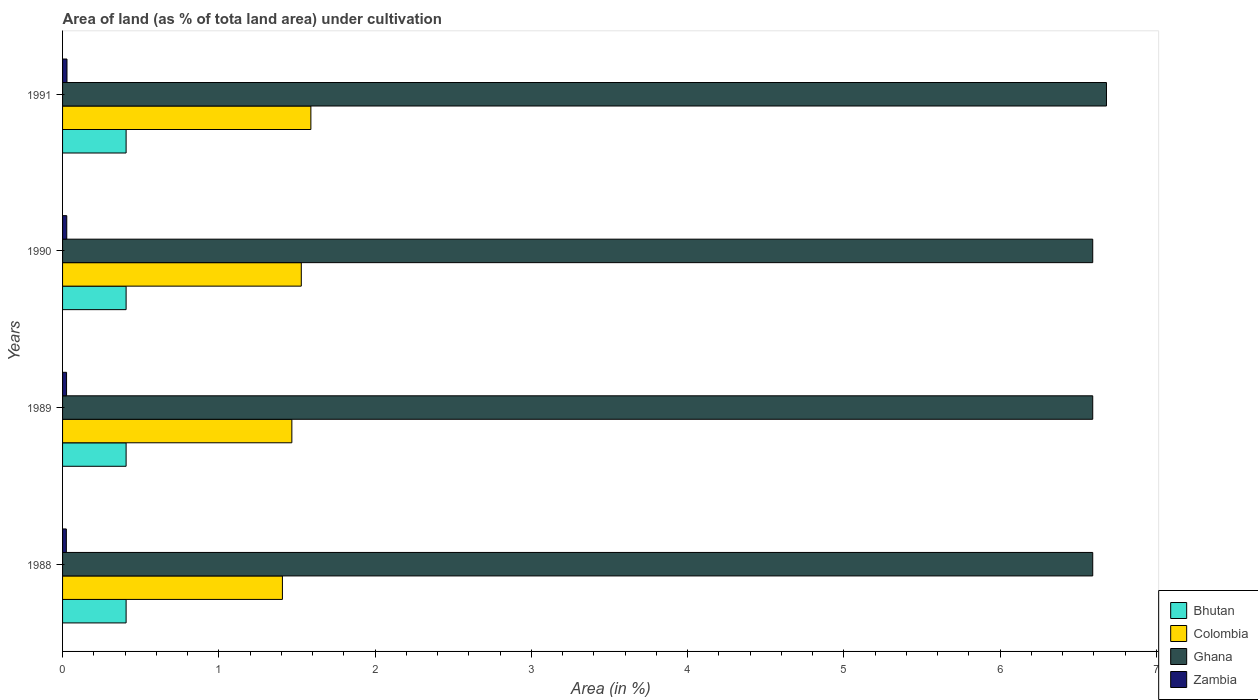How many groups of bars are there?
Your answer should be very brief. 4. How many bars are there on the 2nd tick from the top?
Your answer should be compact. 4. How many bars are there on the 2nd tick from the bottom?
Offer a terse response. 4. What is the label of the 4th group of bars from the top?
Keep it short and to the point. 1988. What is the percentage of land under cultivation in Colombia in 1990?
Your response must be concise. 1.53. Across all years, what is the maximum percentage of land under cultivation in Zambia?
Provide a succinct answer. 0.03. Across all years, what is the minimum percentage of land under cultivation in Zambia?
Make the answer very short. 0.02. In which year was the percentage of land under cultivation in Bhutan minimum?
Ensure brevity in your answer.  1988. What is the total percentage of land under cultivation in Ghana in the graph?
Offer a very short reply. 26.46. What is the difference between the percentage of land under cultivation in Colombia in 1988 and that in 1991?
Your response must be concise. -0.18. What is the difference between the percentage of land under cultivation in Zambia in 1990 and the percentage of land under cultivation in Bhutan in 1989?
Your answer should be compact. -0.38. What is the average percentage of land under cultivation in Bhutan per year?
Provide a succinct answer. 0.41. In the year 1990, what is the difference between the percentage of land under cultivation in Ghana and percentage of land under cultivation in Bhutan?
Provide a short and direct response. 6.19. In how many years, is the percentage of land under cultivation in Zambia greater than 4 %?
Your answer should be very brief. 0. What is the difference between the highest and the second highest percentage of land under cultivation in Bhutan?
Your response must be concise. 0. What is the difference between the highest and the lowest percentage of land under cultivation in Colombia?
Your response must be concise. 0.18. What does the 4th bar from the top in 1988 represents?
Provide a short and direct response. Bhutan. What does the 3rd bar from the bottom in 1989 represents?
Your answer should be very brief. Ghana. How many bars are there?
Your response must be concise. 16. Are all the bars in the graph horizontal?
Your answer should be compact. Yes. How many years are there in the graph?
Ensure brevity in your answer.  4. What is the difference between two consecutive major ticks on the X-axis?
Your answer should be very brief. 1. Does the graph contain any zero values?
Your answer should be compact. No. How many legend labels are there?
Your response must be concise. 4. How are the legend labels stacked?
Offer a terse response. Vertical. What is the title of the graph?
Your answer should be very brief. Area of land (as % of tota land area) under cultivation. What is the label or title of the X-axis?
Offer a terse response. Area (in %). What is the label or title of the Y-axis?
Your answer should be very brief. Years. What is the Area (in %) of Bhutan in 1988?
Keep it short and to the point. 0.41. What is the Area (in %) in Colombia in 1988?
Offer a very short reply. 1.41. What is the Area (in %) of Ghana in 1988?
Provide a succinct answer. 6.59. What is the Area (in %) of Zambia in 1988?
Ensure brevity in your answer.  0.02. What is the Area (in %) in Bhutan in 1989?
Offer a terse response. 0.41. What is the Area (in %) in Colombia in 1989?
Give a very brief answer. 1.47. What is the Area (in %) in Ghana in 1989?
Offer a very short reply. 6.59. What is the Area (in %) in Zambia in 1989?
Ensure brevity in your answer.  0.03. What is the Area (in %) in Bhutan in 1990?
Your response must be concise. 0.41. What is the Area (in %) of Colombia in 1990?
Your response must be concise. 1.53. What is the Area (in %) of Ghana in 1990?
Make the answer very short. 6.59. What is the Area (in %) in Zambia in 1990?
Offer a terse response. 0.03. What is the Area (in %) of Bhutan in 1991?
Provide a succinct answer. 0.41. What is the Area (in %) in Colombia in 1991?
Your answer should be compact. 1.59. What is the Area (in %) of Ghana in 1991?
Provide a succinct answer. 6.68. What is the Area (in %) in Zambia in 1991?
Ensure brevity in your answer.  0.03. Across all years, what is the maximum Area (in %) in Bhutan?
Give a very brief answer. 0.41. Across all years, what is the maximum Area (in %) in Colombia?
Give a very brief answer. 1.59. Across all years, what is the maximum Area (in %) of Ghana?
Your answer should be compact. 6.68. Across all years, what is the maximum Area (in %) of Zambia?
Offer a terse response. 0.03. Across all years, what is the minimum Area (in %) in Bhutan?
Ensure brevity in your answer.  0.41. Across all years, what is the minimum Area (in %) in Colombia?
Your answer should be compact. 1.41. Across all years, what is the minimum Area (in %) of Ghana?
Your answer should be compact. 6.59. Across all years, what is the minimum Area (in %) of Zambia?
Make the answer very short. 0.02. What is the total Area (in %) in Bhutan in the graph?
Offer a terse response. 1.63. What is the total Area (in %) in Colombia in the graph?
Your response must be concise. 5.99. What is the total Area (in %) of Ghana in the graph?
Give a very brief answer. 26.46. What is the total Area (in %) in Zambia in the graph?
Your answer should be very brief. 0.1. What is the difference between the Area (in %) of Colombia in 1988 and that in 1989?
Your response must be concise. -0.06. What is the difference between the Area (in %) in Zambia in 1988 and that in 1989?
Provide a succinct answer. -0. What is the difference between the Area (in %) of Bhutan in 1988 and that in 1990?
Offer a very short reply. 0. What is the difference between the Area (in %) in Colombia in 1988 and that in 1990?
Offer a very short reply. -0.12. What is the difference between the Area (in %) of Zambia in 1988 and that in 1990?
Your response must be concise. -0. What is the difference between the Area (in %) in Colombia in 1988 and that in 1991?
Offer a terse response. -0.18. What is the difference between the Area (in %) of Ghana in 1988 and that in 1991?
Provide a succinct answer. -0.09. What is the difference between the Area (in %) of Zambia in 1988 and that in 1991?
Your answer should be compact. -0. What is the difference between the Area (in %) of Bhutan in 1989 and that in 1990?
Provide a short and direct response. 0. What is the difference between the Area (in %) in Colombia in 1989 and that in 1990?
Provide a short and direct response. -0.06. What is the difference between the Area (in %) in Zambia in 1989 and that in 1990?
Offer a very short reply. -0. What is the difference between the Area (in %) in Colombia in 1989 and that in 1991?
Offer a very short reply. -0.12. What is the difference between the Area (in %) in Ghana in 1989 and that in 1991?
Give a very brief answer. -0.09. What is the difference between the Area (in %) in Zambia in 1989 and that in 1991?
Make the answer very short. -0. What is the difference between the Area (in %) in Bhutan in 1990 and that in 1991?
Keep it short and to the point. 0. What is the difference between the Area (in %) in Colombia in 1990 and that in 1991?
Make the answer very short. -0.06. What is the difference between the Area (in %) in Ghana in 1990 and that in 1991?
Provide a succinct answer. -0.09. What is the difference between the Area (in %) in Zambia in 1990 and that in 1991?
Make the answer very short. -0. What is the difference between the Area (in %) of Bhutan in 1988 and the Area (in %) of Colombia in 1989?
Your response must be concise. -1.06. What is the difference between the Area (in %) in Bhutan in 1988 and the Area (in %) in Ghana in 1989?
Your response must be concise. -6.19. What is the difference between the Area (in %) in Bhutan in 1988 and the Area (in %) in Zambia in 1989?
Keep it short and to the point. 0.38. What is the difference between the Area (in %) of Colombia in 1988 and the Area (in %) of Ghana in 1989?
Ensure brevity in your answer.  -5.19. What is the difference between the Area (in %) in Colombia in 1988 and the Area (in %) in Zambia in 1989?
Give a very brief answer. 1.38. What is the difference between the Area (in %) in Ghana in 1988 and the Area (in %) in Zambia in 1989?
Give a very brief answer. 6.57. What is the difference between the Area (in %) of Bhutan in 1988 and the Area (in %) of Colombia in 1990?
Make the answer very short. -1.12. What is the difference between the Area (in %) in Bhutan in 1988 and the Area (in %) in Ghana in 1990?
Offer a terse response. -6.19. What is the difference between the Area (in %) in Bhutan in 1988 and the Area (in %) in Zambia in 1990?
Keep it short and to the point. 0.38. What is the difference between the Area (in %) of Colombia in 1988 and the Area (in %) of Ghana in 1990?
Provide a succinct answer. -5.19. What is the difference between the Area (in %) of Colombia in 1988 and the Area (in %) of Zambia in 1990?
Offer a very short reply. 1.38. What is the difference between the Area (in %) of Ghana in 1988 and the Area (in %) of Zambia in 1990?
Make the answer very short. 6.57. What is the difference between the Area (in %) in Bhutan in 1988 and the Area (in %) in Colombia in 1991?
Give a very brief answer. -1.18. What is the difference between the Area (in %) of Bhutan in 1988 and the Area (in %) of Ghana in 1991?
Your response must be concise. -6.27. What is the difference between the Area (in %) of Bhutan in 1988 and the Area (in %) of Zambia in 1991?
Provide a short and direct response. 0.38. What is the difference between the Area (in %) in Colombia in 1988 and the Area (in %) in Ghana in 1991?
Provide a succinct answer. -5.27. What is the difference between the Area (in %) in Colombia in 1988 and the Area (in %) in Zambia in 1991?
Provide a succinct answer. 1.38. What is the difference between the Area (in %) of Ghana in 1988 and the Area (in %) of Zambia in 1991?
Ensure brevity in your answer.  6.56. What is the difference between the Area (in %) of Bhutan in 1989 and the Area (in %) of Colombia in 1990?
Your answer should be compact. -1.12. What is the difference between the Area (in %) of Bhutan in 1989 and the Area (in %) of Ghana in 1990?
Give a very brief answer. -6.19. What is the difference between the Area (in %) of Bhutan in 1989 and the Area (in %) of Zambia in 1990?
Your answer should be very brief. 0.38. What is the difference between the Area (in %) of Colombia in 1989 and the Area (in %) of Ghana in 1990?
Make the answer very short. -5.12. What is the difference between the Area (in %) of Colombia in 1989 and the Area (in %) of Zambia in 1990?
Keep it short and to the point. 1.44. What is the difference between the Area (in %) in Ghana in 1989 and the Area (in %) in Zambia in 1990?
Give a very brief answer. 6.57. What is the difference between the Area (in %) of Bhutan in 1989 and the Area (in %) of Colombia in 1991?
Your answer should be very brief. -1.18. What is the difference between the Area (in %) of Bhutan in 1989 and the Area (in %) of Ghana in 1991?
Make the answer very short. -6.27. What is the difference between the Area (in %) of Bhutan in 1989 and the Area (in %) of Zambia in 1991?
Give a very brief answer. 0.38. What is the difference between the Area (in %) in Colombia in 1989 and the Area (in %) in Ghana in 1991?
Offer a very short reply. -5.21. What is the difference between the Area (in %) of Colombia in 1989 and the Area (in %) of Zambia in 1991?
Keep it short and to the point. 1.44. What is the difference between the Area (in %) in Ghana in 1989 and the Area (in %) in Zambia in 1991?
Keep it short and to the point. 6.56. What is the difference between the Area (in %) of Bhutan in 1990 and the Area (in %) of Colombia in 1991?
Give a very brief answer. -1.18. What is the difference between the Area (in %) in Bhutan in 1990 and the Area (in %) in Ghana in 1991?
Provide a short and direct response. -6.27. What is the difference between the Area (in %) in Bhutan in 1990 and the Area (in %) in Zambia in 1991?
Give a very brief answer. 0.38. What is the difference between the Area (in %) in Colombia in 1990 and the Area (in %) in Ghana in 1991?
Offer a terse response. -5.15. What is the difference between the Area (in %) of Colombia in 1990 and the Area (in %) of Zambia in 1991?
Offer a very short reply. 1.5. What is the difference between the Area (in %) in Ghana in 1990 and the Area (in %) in Zambia in 1991?
Offer a terse response. 6.56. What is the average Area (in %) of Bhutan per year?
Ensure brevity in your answer.  0.41. What is the average Area (in %) of Colombia per year?
Your answer should be compact. 1.5. What is the average Area (in %) of Ghana per year?
Make the answer very short. 6.61. What is the average Area (in %) of Zambia per year?
Offer a very short reply. 0.03. In the year 1988, what is the difference between the Area (in %) of Bhutan and Area (in %) of Colombia?
Offer a terse response. -1. In the year 1988, what is the difference between the Area (in %) of Bhutan and Area (in %) of Ghana?
Offer a terse response. -6.19. In the year 1988, what is the difference between the Area (in %) in Bhutan and Area (in %) in Zambia?
Give a very brief answer. 0.38. In the year 1988, what is the difference between the Area (in %) in Colombia and Area (in %) in Ghana?
Keep it short and to the point. -5.19. In the year 1988, what is the difference between the Area (in %) of Colombia and Area (in %) of Zambia?
Ensure brevity in your answer.  1.38. In the year 1988, what is the difference between the Area (in %) of Ghana and Area (in %) of Zambia?
Offer a terse response. 6.57. In the year 1989, what is the difference between the Area (in %) in Bhutan and Area (in %) in Colombia?
Your answer should be very brief. -1.06. In the year 1989, what is the difference between the Area (in %) of Bhutan and Area (in %) of Ghana?
Provide a succinct answer. -6.19. In the year 1989, what is the difference between the Area (in %) in Bhutan and Area (in %) in Zambia?
Your answer should be very brief. 0.38. In the year 1989, what is the difference between the Area (in %) of Colombia and Area (in %) of Ghana?
Your response must be concise. -5.12. In the year 1989, what is the difference between the Area (in %) of Colombia and Area (in %) of Zambia?
Your response must be concise. 1.44. In the year 1989, what is the difference between the Area (in %) of Ghana and Area (in %) of Zambia?
Offer a terse response. 6.57. In the year 1990, what is the difference between the Area (in %) in Bhutan and Area (in %) in Colombia?
Ensure brevity in your answer.  -1.12. In the year 1990, what is the difference between the Area (in %) of Bhutan and Area (in %) of Ghana?
Keep it short and to the point. -6.19. In the year 1990, what is the difference between the Area (in %) of Bhutan and Area (in %) of Zambia?
Provide a short and direct response. 0.38. In the year 1990, what is the difference between the Area (in %) of Colombia and Area (in %) of Ghana?
Make the answer very short. -5.06. In the year 1990, what is the difference between the Area (in %) in Colombia and Area (in %) in Zambia?
Your response must be concise. 1.5. In the year 1990, what is the difference between the Area (in %) of Ghana and Area (in %) of Zambia?
Your answer should be very brief. 6.57. In the year 1991, what is the difference between the Area (in %) of Bhutan and Area (in %) of Colombia?
Offer a terse response. -1.18. In the year 1991, what is the difference between the Area (in %) in Bhutan and Area (in %) in Ghana?
Offer a very short reply. -6.27. In the year 1991, what is the difference between the Area (in %) of Bhutan and Area (in %) of Zambia?
Your response must be concise. 0.38. In the year 1991, what is the difference between the Area (in %) in Colombia and Area (in %) in Ghana?
Provide a short and direct response. -5.09. In the year 1991, what is the difference between the Area (in %) of Colombia and Area (in %) of Zambia?
Your answer should be compact. 1.56. In the year 1991, what is the difference between the Area (in %) of Ghana and Area (in %) of Zambia?
Your answer should be very brief. 6.65. What is the ratio of the Area (in %) of Colombia in 1988 to that in 1989?
Your answer should be very brief. 0.96. What is the ratio of the Area (in %) in Ghana in 1988 to that in 1989?
Keep it short and to the point. 1. What is the ratio of the Area (in %) of Bhutan in 1988 to that in 1990?
Your response must be concise. 1. What is the ratio of the Area (in %) in Colombia in 1988 to that in 1990?
Make the answer very short. 0.92. What is the ratio of the Area (in %) of Ghana in 1988 to that in 1990?
Your response must be concise. 1. What is the ratio of the Area (in %) in Zambia in 1988 to that in 1990?
Give a very brief answer. 0.9. What is the ratio of the Area (in %) of Colombia in 1988 to that in 1991?
Make the answer very short. 0.89. What is the ratio of the Area (in %) of Ghana in 1988 to that in 1991?
Offer a terse response. 0.99. What is the ratio of the Area (in %) of Zambia in 1988 to that in 1991?
Your answer should be very brief. 0.86. What is the ratio of the Area (in %) in Colombia in 1989 to that in 1990?
Offer a terse response. 0.96. What is the ratio of the Area (in %) of Zambia in 1989 to that in 1990?
Your answer should be compact. 0.95. What is the ratio of the Area (in %) of Colombia in 1989 to that in 1991?
Your answer should be compact. 0.92. What is the ratio of the Area (in %) of Ghana in 1989 to that in 1991?
Your response must be concise. 0.99. What is the ratio of the Area (in %) in Zambia in 1989 to that in 1991?
Make the answer very short. 0.9. What is the ratio of the Area (in %) of Bhutan in 1990 to that in 1991?
Provide a short and direct response. 1. What is the ratio of the Area (in %) of Colombia in 1990 to that in 1991?
Offer a very short reply. 0.96. What is the ratio of the Area (in %) in Ghana in 1990 to that in 1991?
Your answer should be compact. 0.99. What is the difference between the highest and the second highest Area (in %) of Colombia?
Your answer should be very brief. 0.06. What is the difference between the highest and the second highest Area (in %) of Ghana?
Offer a very short reply. 0.09. What is the difference between the highest and the second highest Area (in %) in Zambia?
Keep it short and to the point. 0. What is the difference between the highest and the lowest Area (in %) of Bhutan?
Provide a short and direct response. 0. What is the difference between the highest and the lowest Area (in %) of Colombia?
Keep it short and to the point. 0.18. What is the difference between the highest and the lowest Area (in %) in Ghana?
Offer a very short reply. 0.09. What is the difference between the highest and the lowest Area (in %) in Zambia?
Your response must be concise. 0. 